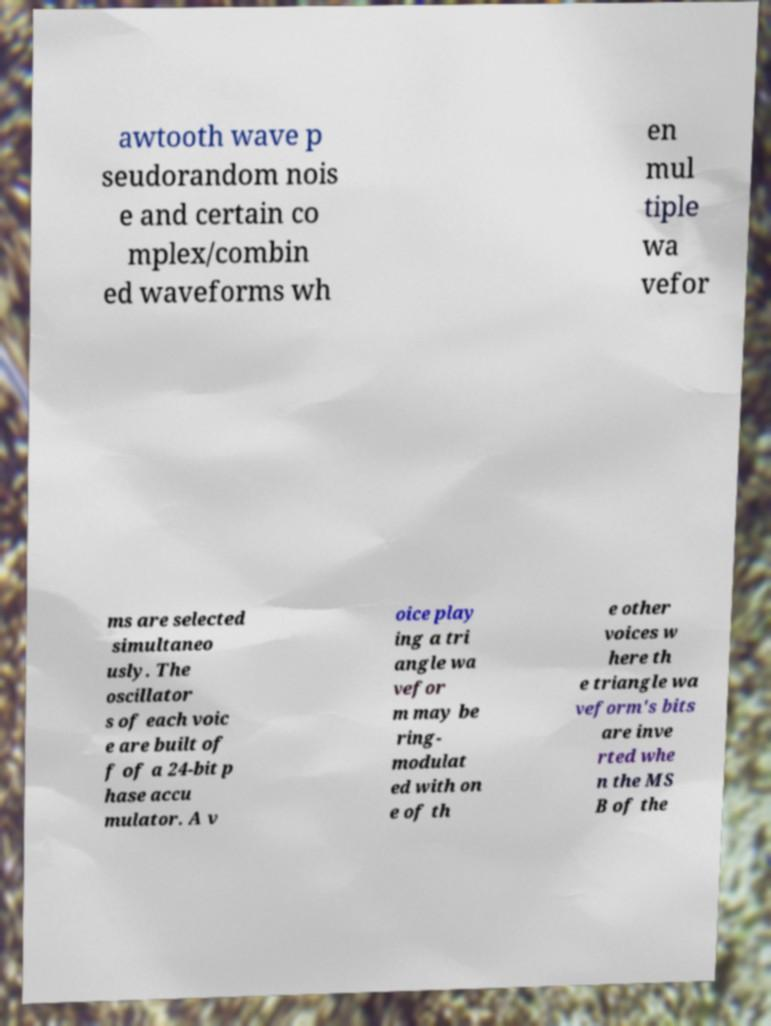For documentation purposes, I need the text within this image transcribed. Could you provide that? awtooth wave p seudorandom nois e and certain co mplex/combin ed waveforms wh en mul tiple wa vefor ms are selected simultaneo usly. The oscillator s of each voic e are built of f of a 24-bit p hase accu mulator. A v oice play ing a tri angle wa vefor m may be ring- modulat ed with on e of th e other voices w here th e triangle wa veform's bits are inve rted whe n the MS B of the 